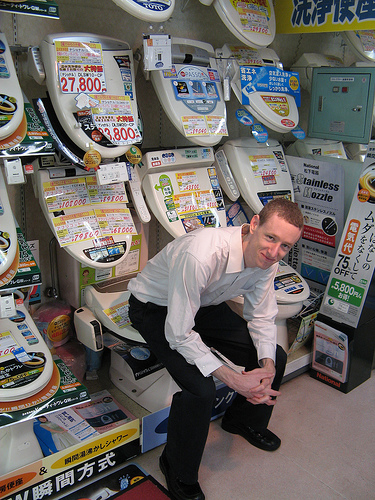Is the boy to the left or to the right of the container that is on the left side? The boy is positioned to the right of the container on the left side, engaging the audience with a playful demonstration. 